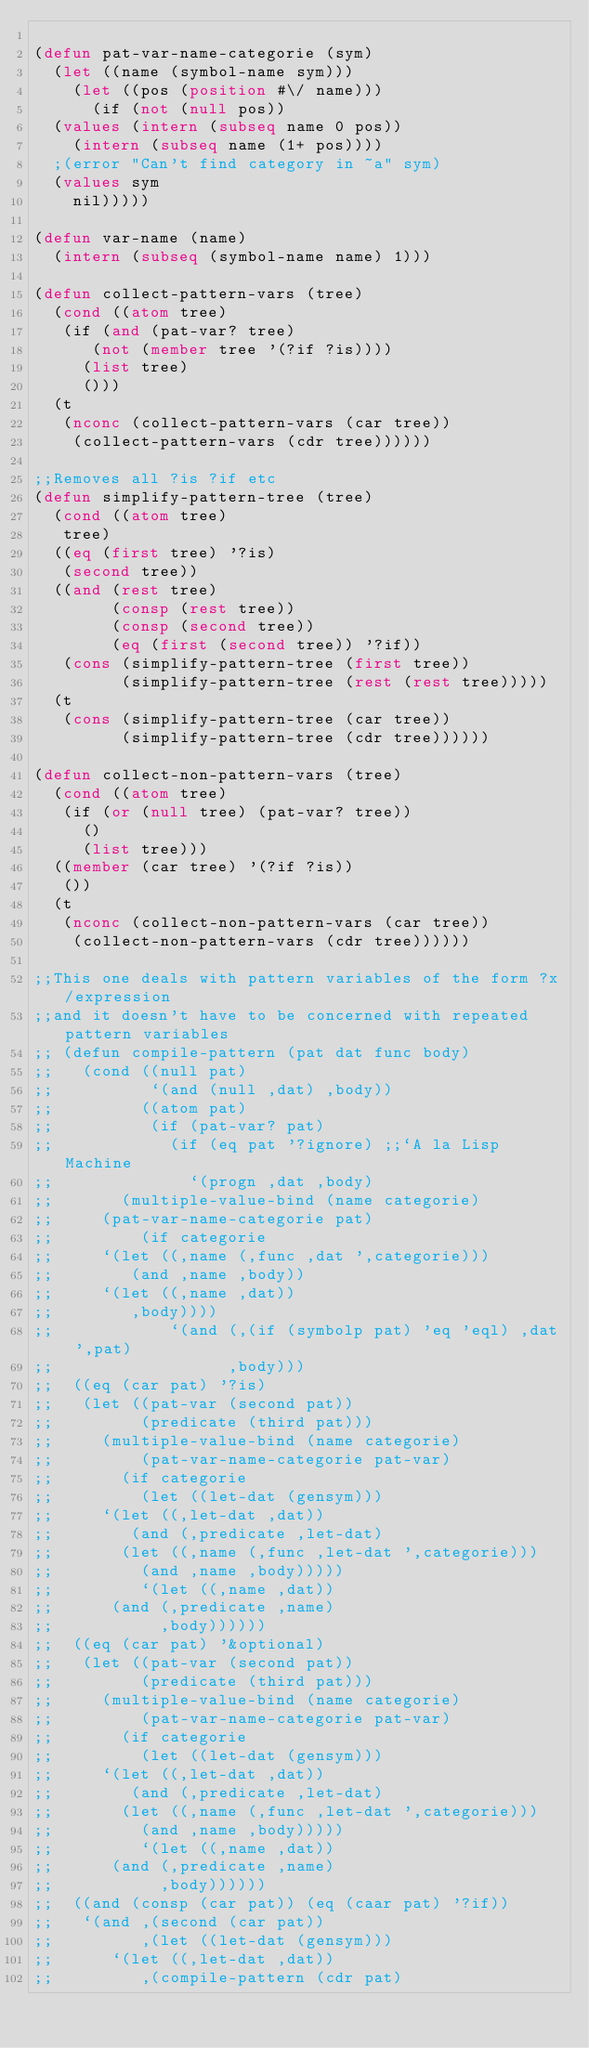Convert code to text. <code><loc_0><loc_0><loc_500><loc_500><_Lisp_>
(defun pat-var-name-categorie (sym)
  (let ((name (symbol-name sym)))
    (let ((pos (position #\/ name)))
      (if (not (null pos))
	(values (intern (subseq name 0 pos))
		(intern (subseq name (1+ pos))))
	;(error "Can't find category in ~a" sym)
	(values sym
		nil)))))

(defun var-name (name)
  (intern (subseq (symbol-name name) 1)))

(defun collect-pattern-vars (tree)
  (cond ((atom tree)
	 (if (and (pat-var? tree)
		  (not (member tree '(?if ?is))))
	   (list tree)
	   ()))
	(t 
	 (nconc (collect-pattern-vars (car tree))
		(collect-pattern-vars (cdr tree))))))

;;Removes all ?is ?if etc
(defun simplify-pattern-tree (tree)
  (cond ((atom tree)
	 tree)
	((eq (first tree) '?is)
	 (second tree))
	((and (rest tree)
	      (consp (rest tree))
	      (consp (second tree))
	      (eq (first (second tree)) '?if))
	 (cons (simplify-pattern-tree (first tree))
	       (simplify-pattern-tree (rest (rest tree)))))
	(t 
	 (cons (simplify-pattern-tree (car tree))
	       (simplify-pattern-tree (cdr tree))))))

(defun collect-non-pattern-vars (tree)
  (cond ((atom tree)
	 (if (or (null tree) (pat-var? tree))
	   ()
	   (list tree)))
	((member (car tree) '(?if ?is))
	 ())
	(t 
	 (nconc (collect-non-pattern-vars (car tree))
		(collect-non-pattern-vars (cdr tree))))))

;;This one deals with pattern variables of the form ?x/expression
;;and it doesn't have to be concerned with repeated pattern variables
;; (defun compile-pattern (pat dat func body)
;;   (cond ((null pat)
;;          `(and (null ,dat) ,body))
;;         ((atom pat)
;;          (if (pat-var? pat)
;;            (if (eq pat '?ignore) ;;`A la Lisp Machine
;;              `(progn ,dat ,body)
;; 	     (multiple-value-bind (name categorie) 
;; 		 (pat-var-name-categorie pat)
;; 	       (if categorie
;; 		 `(let ((,name (,func ,dat ',categorie)))
;; 		    (and ,name ,body))
;; 		 `(let ((,name ,dat))
;; 		    ,body))))
;;            `(and (,(if (symbolp pat) 'eq 'eql) ,dat ',pat) 
;;                  ,body)))
;; 	((eq (car pat) '?is)
;; 	 (let ((pat-var (second pat))
;; 	       (predicate (third pat)))
;; 	   (multiple-value-bind (name categorie) 
;; 	       (pat-var-name-categorie pat-var)
;; 	     (if categorie
;; 	       (let ((let-dat (gensym)))
;; 		 `(let ((,let-dat ,dat))
;; 		    (and (,predicate ,let-dat)
;; 			 (let ((,name (,func ,let-dat ',categorie)))
;; 			   (and ,name ,body)))))
;; 	       `(let ((,name ,dat))
;; 		  (and (,predicate ,name)
;; 		       ,body))))))
;; 	((eq (car pat) '&optional)
;; 	 (let ((pat-var (second pat))
;; 	       (predicate (third pat)))
;; 	   (multiple-value-bind (name categorie) 
;; 	       (pat-var-name-categorie pat-var)
;; 	     (if categorie
;; 	       (let ((let-dat (gensym)))
;; 		 `(let ((,let-dat ,dat))
;; 		    (and (,predicate ,let-dat)
;; 			 (let ((,name (,func ,let-dat ',categorie)))
;; 			   (and ,name ,body)))))
;; 	       `(let ((,name ,dat))
;; 		  (and (,predicate ,name)
;; 		       ,body))))))
;; 	((and (consp (car pat)) (eq (caar pat) '?if))
;; 	 `(and ,(second (car pat))
;; 	       ,(let ((let-dat (gensym)))
;; 		  `(let ((,let-dat ,dat))
;; 		     ,(compile-pattern (cdr pat) </code> 